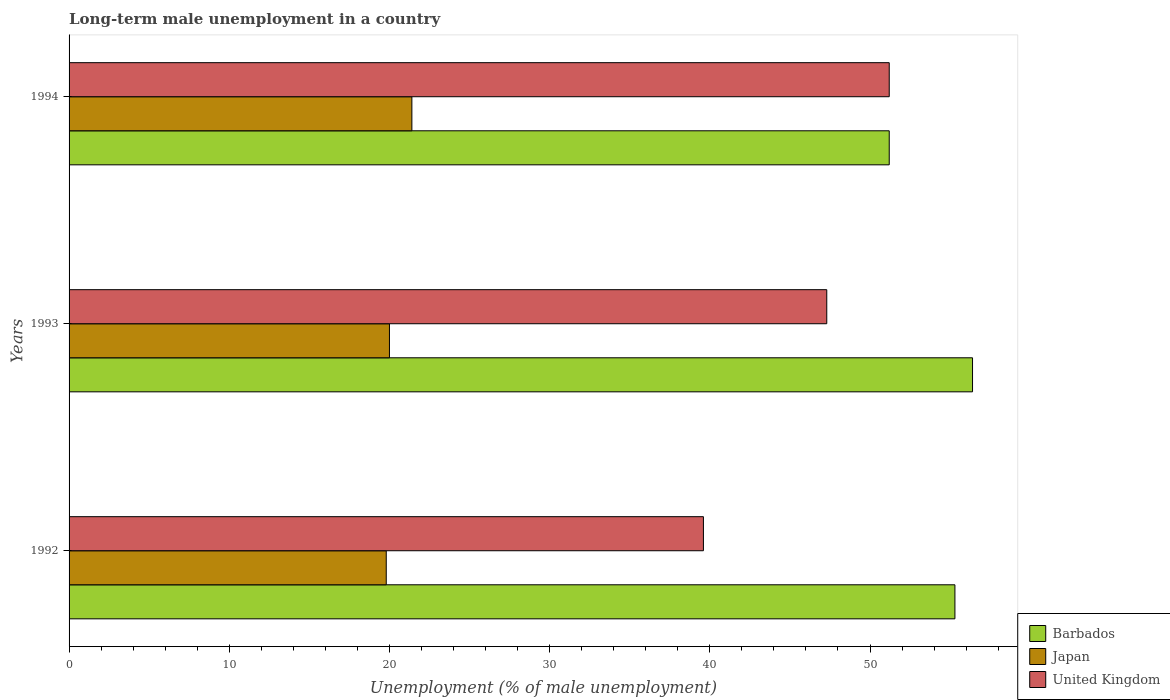How many different coloured bars are there?
Give a very brief answer. 3. How many groups of bars are there?
Give a very brief answer. 3. Are the number of bars on each tick of the Y-axis equal?
Give a very brief answer. Yes. How many bars are there on the 2nd tick from the bottom?
Your response must be concise. 3. What is the label of the 2nd group of bars from the top?
Give a very brief answer. 1993. What is the percentage of long-term unemployed male population in United Kingdom in 1994?
Offer a terse response. 51.2. Across all years, what is the maximum percentage of long-term unemployed male population in Japan?
Keep it short and to the point. 21.4. Across all years, what is the minimum percentage of long-term unemployed male population in Japan?
Your answer should be compact. 19.8. In which year was the percentage of long-term unemployed male population in United Kingdom maximum?
Offer a very short reply. 1994. In which year was the percentage of long-term unemployed male population in Japan minimum?
Provide a succinct answer. 1992. What is the total percentage of long-term unemployed male population in Japan in the graph?
Your answer should be very brief. 61.2. What is the difference between the percentage of long-term unemployed male population in Barbados in 1992 and that in 1994?
Provide a short and direct response. 4.1. What is the difference between the percentage of long-term unemployed male population in United Kingdom in 1994 and the percentage of long-term unemployed male population in Japan in 1992?
Offer a terse response. 31.4. What is the average percentage of long-term unemployed male population in Japan per year?
Your answer should be very brief. 20.4. What is the ratio of the percentage of long-term unemployed male population in United Kingdom in 1992 to that in 1993?
Your response must be concise. 0.84. Is the percentage of long-term unemployed male population in Japan in 1992 less than that in 1994?
Provide a short and direct response. Yes. What is the difference between the highest and the second highest percentage of long-term unemployed male population in Japan?
Ensure brevity in your answer.  1.4. What is the difference between the highest and the lowest percentage of long-term unemployed male population in Barbados?
Ensure brevity in your answer.  5.2. What does the 1st bar from the top in 1992 represents?
Keep it short and to the point. United Kingdom. What does the 3rd bar from the bottom in 1992 represents?
Offer a terse response. United Kingdom. What is the difference between two consecutive major ticks on the X-axis?
Give a very brief answer. 10. Are the values on the major ticks of X-axis written in scientific E-notation?
Make the answer very short. No. What is the title of the graph?
Offer a terse response. Long-term male unemployment in a country. What is the label or title of the X-axis?
Give a very brief answer. Unemployment (% of male unemployment). What is the Unemployment (% of male unemployment) in Barbados in 1992?
Your response must be concise. 55.3. What is the Unemployment (% of male unemployment) of Japan in 1992?
Give a very brief answer. 19.8. What is the Unemployment (% of male unemployment) of United Kingdom in 1992?
Give a very brief answer. 39.6. What is the Unemployment (% of male unemployment) in Barbados in 1993?
Keep it short and to the point. 56.4. What is the Unemployment (% of male unemployment) of Japan in 1993?
Offer a terse response. 20. What is the Unemployment (% of male unemployment) of United Kingdom in 1993?
Offer a terse response. 47.3. What is the Unemployment (% of male unemployment) in Barbados in 1994?
Give a very brief answer. 51.2. What is the Unemployment (% of male unemployment) in Japan in 1994?
Ensure brevity in your answer.  21.4. What is the Unemployment (% of male unemployment) of United Kingdom in 1994?
Offer a terse response. 51.2. Across all years, what is the maximum Unemployment (% of male unemployment) in Barbados?
Your response must be concise. 56.4. Across all years, what is the maximum Unemployment (% of male unemployment) of Japan?
Give a very brief answer. 21.4. Across all years, what is the maximum Unemployment (% of male unemployment) in United Kingdom?
Give a very brief answer. 51.2. Across all years, what is the minimum Unemployment (% of male unemployment) in Barbados?
Keep it short and to the point. 51.2. Across all years, what is the minimum Unemployment (% of male unemployment) of Japan?
Make the answer very short. 19.8. Across all years, what is the minimum Unemployment (% of male unemployment) in United Kingdom?
Offer a terse response. 39.6. What is the total Unemployment (% of male unemployment) of Barbados in the graph?
Provide a short and direct response. 162.9. What is the total Unemployment (% of male unemployment) in Japan in the graph?
Give a very brief answer. 61.2. What is the total Unemployment (% of male unemployment) of United Kingdom in the graph?
Provide a short and direct response. 138.1. What is the difference between the Unemployment (% of male unemployment) in Barbados in 1992 and that in 1993?
Ensure brevity in your answer.  -1.1. What is the difference between the Unemployment (% of male unemployment) in Japan in 1992 and that in 1993?
Your answer should be very brief. -0.2. What is the difference between the Unemployment (% of male unemployment) in Japan in 1993 and that in 1994?
Your response must be concise. -1.4. What is the difference between the Unemployment (% of male unemployment) of United Kingdom in 1993 and that in 1994?
Ensure brevity in your answer.  -3.9. What is the difference between the Unemployment (% of male unemployment) of Barbados in 1992 and the Unemployment (% of male unemployment) of Japan in 1993?
Give a very brief answer. 35.3. What is the difference between the Unemployment (% of male unemployment) of Barbados in 1992 and the Unemployment (% of male unemployment) of United Kingdom in 1993?
Your answer should be compact. 8. What is the difference between the Unemployment (% of male unemployment) of Japan in 1992 and the Unemployment (% of male unemployment) of United Kingdom in 1993?
Provide a succinct answer. -27.5. What is the difference between the Unemployment (% of male unemployment) in Barbados in 1992 and the Unemployment (% of male unemployment) in Japan in 1994?
Offer a very short reply. 33.9. What is the difference between the Unemployment (% of male unemployment) of Barbados in 1992 and the Unemployment (% of male unemployment) of United Kingdom in 1994?
Offer a terse response. 4.1. What is the difference between the Unemployment (% of male unemployment) of Japan in 1992 and the Unemployment (% of male unemployment) of United Kingdom in 1994?
Give a very brief answer. -31.4. What is the difference between the Unemployment (% of male unemployment) in Barbados in 1993 and the Unemployment (% of male unemployment) in Japan in 1994?
Your response must be concise. 35. What is the difference between the Unemployment (% of male unemployment) of Japan in 1993 and the Unemployment (% of male unemployment) of United Kingdom in 1994?
Your answer should be very brief. -31.2. What is the average Unemployment (% of male unemployment) in Barbados per year?
Give a very brief answer. 54.3. What is the average Unemployment (% of male unemployment) in Japan per year?
Offer a very short reply. 20.4. What is the average Unemployment (% of male unemployment) of United Kingdom per year?
Your answer should be very brief. 46.03. In the year 1992, what is the difference between the Unemployment (% of male unemployment) in Barbados and Unemployment (% of male unemployment) in Japan?
Make the answer very short. 35.5. In the year 1992, what is the difference between the Unemployment (% of male unemployment) of Barbados and Unemployment (% of male unemployment) of United Kingdom?
Ensure brevity in your answer.  15.7. In the year 1992, what is the difference between the Unemployment (% of male unemployment) of Japan and Unemployment (% of male unemployment) of United Kingdom?
Give a very brief answer. -19.8. In the year 1993, what is the difference between the Unemployment (% of male unemployment) of Barbados and Unemployment (% of male unemployment) of Japan?
Provide a short and direct response. 36.4. In the year 1993, what is the difference between the Unemployment (% of male unemployment) in Japan and Unemployment (% of male unemployment) in United Kingdom?
Your answer should be compact. -27.3. In the year 1994, what is the difference between the Unemployment (% of male unemployment) of Barbados and Unemployment (% of male unemployment) of Japan?
Your answer should be compact. 29.8. In the year 1994, what is the difference between the Unemployment (% of male unemployment) of Barbados and Unemployment (% of male unemployment) of United Kingdom?
Ensure brevity in your answer.  0. In the year 1994, what is the difference between the Unemployment (% of male unemployment) in Japan and Unemployment (% of male unemployment) in United Kingdom?
Offer a terse response. -29.8. What is the ratio of the Unemployment (% of male unemployment) in Barbados in 1992 to that in 1993?
Make the answer very short. 0.98. What is the ratio of the Unemployment (% of male unemployment) of United Kingdom in 1992 to that in 1993?
Your answer should be very brief. 0.84. What is the ratio of the Unemployment (% of male unemployment) in Barbados in 1992 to that in 1994?
Provide a short and direct response. 1.08. What is the ratio of the Unemployment (% of male unemployment) of Japan in 1992 to that in 1994?
Give a very brief answer. 0.93. What is the ratio of the Unemployment (% of male unemployment) of United Kingdom in 1992 to that in 1994?
Your response must be concise. 0.77. What is the ratio of the Unemployment (% of male unemployment) in Barbados in 1993 to that in 1994?
Keep it short and to the point. 1.1. What is the ratio of the Unemployment (% of male unemployment) in Japan in 1993 to that in 1994?
Offer a very short reply. 0.93. What is the ratio of the Unemployment (% of male unemployment) in United Kingdom in 1993 to that in 1994?
Make the answer very short. 0.92. What is the difference between the highest and the second highest Unemployment (% of male unemployment) in Japan?
Provide a succinct answer. 1.4. 